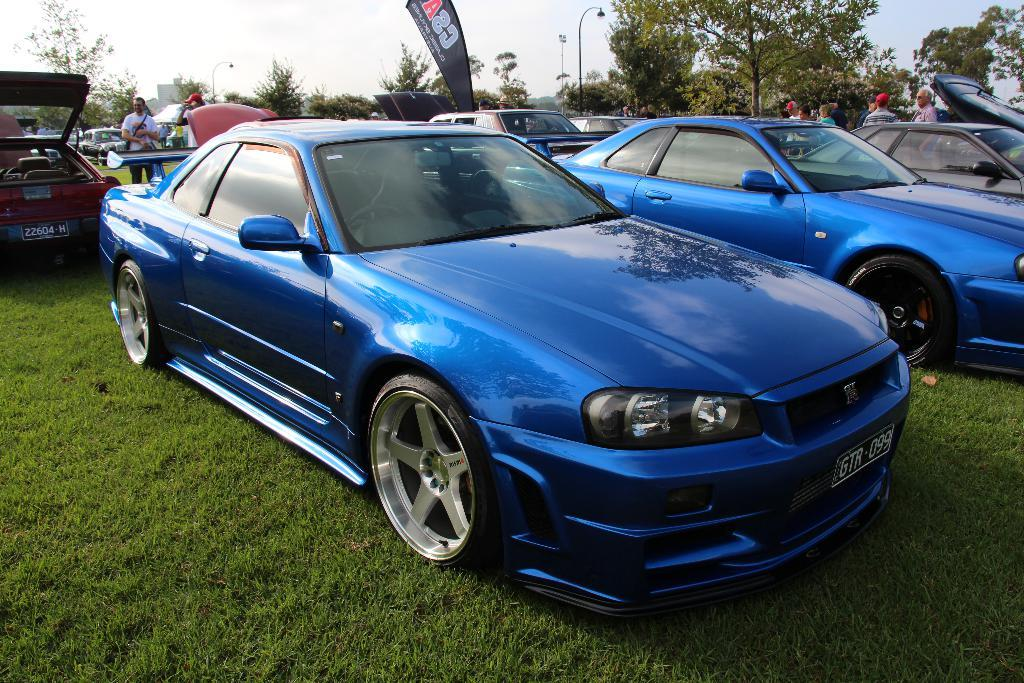What type of surface are the cars parked on in the image? The cars are parked on a grass floor in the image. What natural elements can be seen in the image? There are trees in the image. What man-made structures are present in the image? There are poles in the image. Who or what is present in the image besides the cars and trees? There are people in the image. Can you describe any other objects or features in the image? There are other unspecified objects in the image. What type of letter is being delivered to the person in the image? There is no letter or delivery person present in the image. How hot is the temperature in the image? The temperature is not mentioned or depicted in the image. 